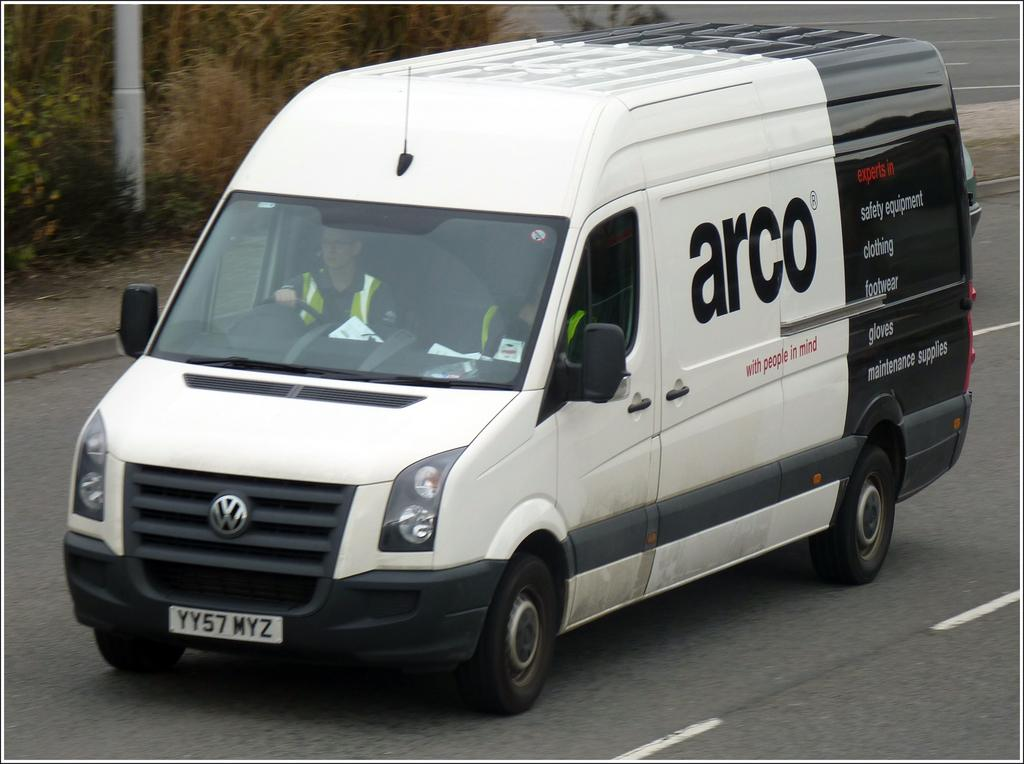<image>
Give a short and clear explanation of the subsequent image. A black-and-white van labeled with the company name "Arco" drives down a road. 